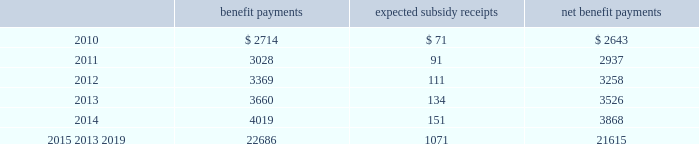Mastercard incorporated notes to consolidated financial statements 2014 ( continued ) ( in thousands , except percent and per share data ) the company does not make any contributions to its postretirement plan other than funding benefits payments .
The table summarizes expected net benefit payments from the company 2019s general assets through 2019 : benefit payments expected subsidy receipts benefit payments .
The company provides limited postemployment benefits to eligible former u.s .
Employees , primarily severance under a formal severance plan ( the 201cseverance plan 201d ) .
The company accounts for severance expense by accruing the expected cost of the severance benefits expected to be provided to former employees after employment over their relevant service periods .
The company updates the assumptions in determining the severance accrual by evaluating the actual severance activity and long-term trends underlying the assumptions .
As a result of updating the assumptions , the company recorded incremental severance expense ( benefit ) related to the severance plan of $ 3471 , $ 2643 and $ ( 3418 ) , respectively , during the years 2009 , 2008 and 2007 .
These amounts were part of total severance expenses of $ 135113 , $ 32997 and $ 21284 in 2009 , 2008 and 2007 , respectively , included in general and administrative expenses in the accompanying consolidated statements of operations .
Note 14 .
Debt on april 28 , 2008 , the company extended its committed unsecured revolving credit facility , dated as of april 28 , 2006 ( the 201ccredit facility 201d ) , for an additional year .
The new expiration date of the credit facility is april 26 , 2011 .
The available funding under the credit facility will remain at $ 2500000 through april 27 , 2010 and then decrease to $ 2000000 during the final year of the credit facility agreement .
Other terms and conditions in the credit facility remain unchanged .
The company 2019s option to request that each lender under the credit facility extend its commitment was provided pursuant to the original terms of the credit facility agreement .
Borrowings under the facility are available to provide liquidity in the event of one or more settlement failures by mastercard international customers and , subject to a limit of $ 500000 , for general corporate purposes .
The facility fee and borrowing cost are contingent upon the company 2019s credit rating .
At december 31 , 2009 , the facility fee was 7 basis points on the total commitment , or approximately $ 1774 annually .
Interest on borrowings under the credit facility would be charged at the london interbank offered rate ( libor ) plus an applicable margin of 28 basis points or an alternative base rate , and a utilization fee of 10 basis points would be charged if outstanding borrowings under the facility exceed 50% ( 50 % ) of commitments .
At the inception of the credit facility , the company also agreed to pay upfront fees of $ 1250 and administrative fees of $ 325 , which are being amortized over five years .
Facility and other fees associated with the credit facility totaled $ 2222 , $ 2353 and $ 2477 for each of the years ended december 31 , 2009 , 2008 and 2007 , respectively .
Mastercard was in compliance with the covenants of the credit facility and had no borrowings under the credit facility at december 31 , 2009 or december 31 , 2008 .
The majority of credit facility lenders are members or affiliates of members of mastercard international .
In june 1998 , mastercard international issued ten-year unsecured , subordinated notes ( the 201cnotes 201d ) paying a fixed interest rate of 6.67% ( 6.67 % ) per annum .
Mastercard repaid the entire principal amount of $ 80000 on june 30 , 2008 pursuant to the terms of the notes .
The interest expense on the notes was $ 2668 and $ 5336 for each of the years ended december 31 , 2008 and 2007 , respectively. .
What is the average yearly benefit payment for the years 2015-2019? 
Rationale: it is the sum of all benefit payments for the years 2015-2019 divided by five ( the period ) .
Computations: (22686 / 5)
Answer: 4537.2. 